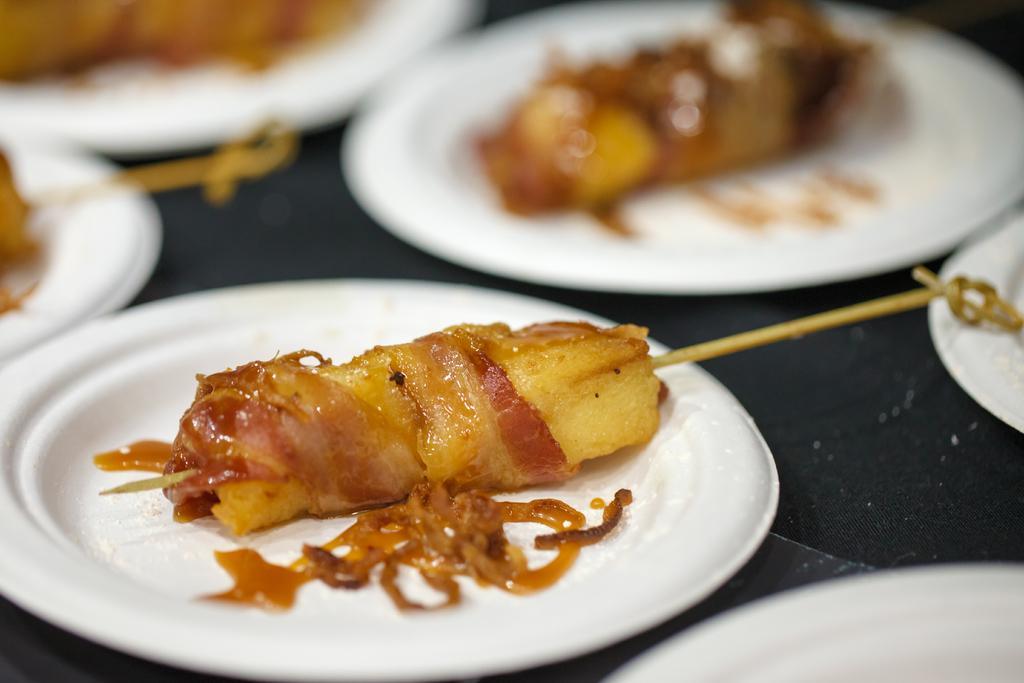Can you describe this image briefly? In this picture there are few eatables placed in white plates. 